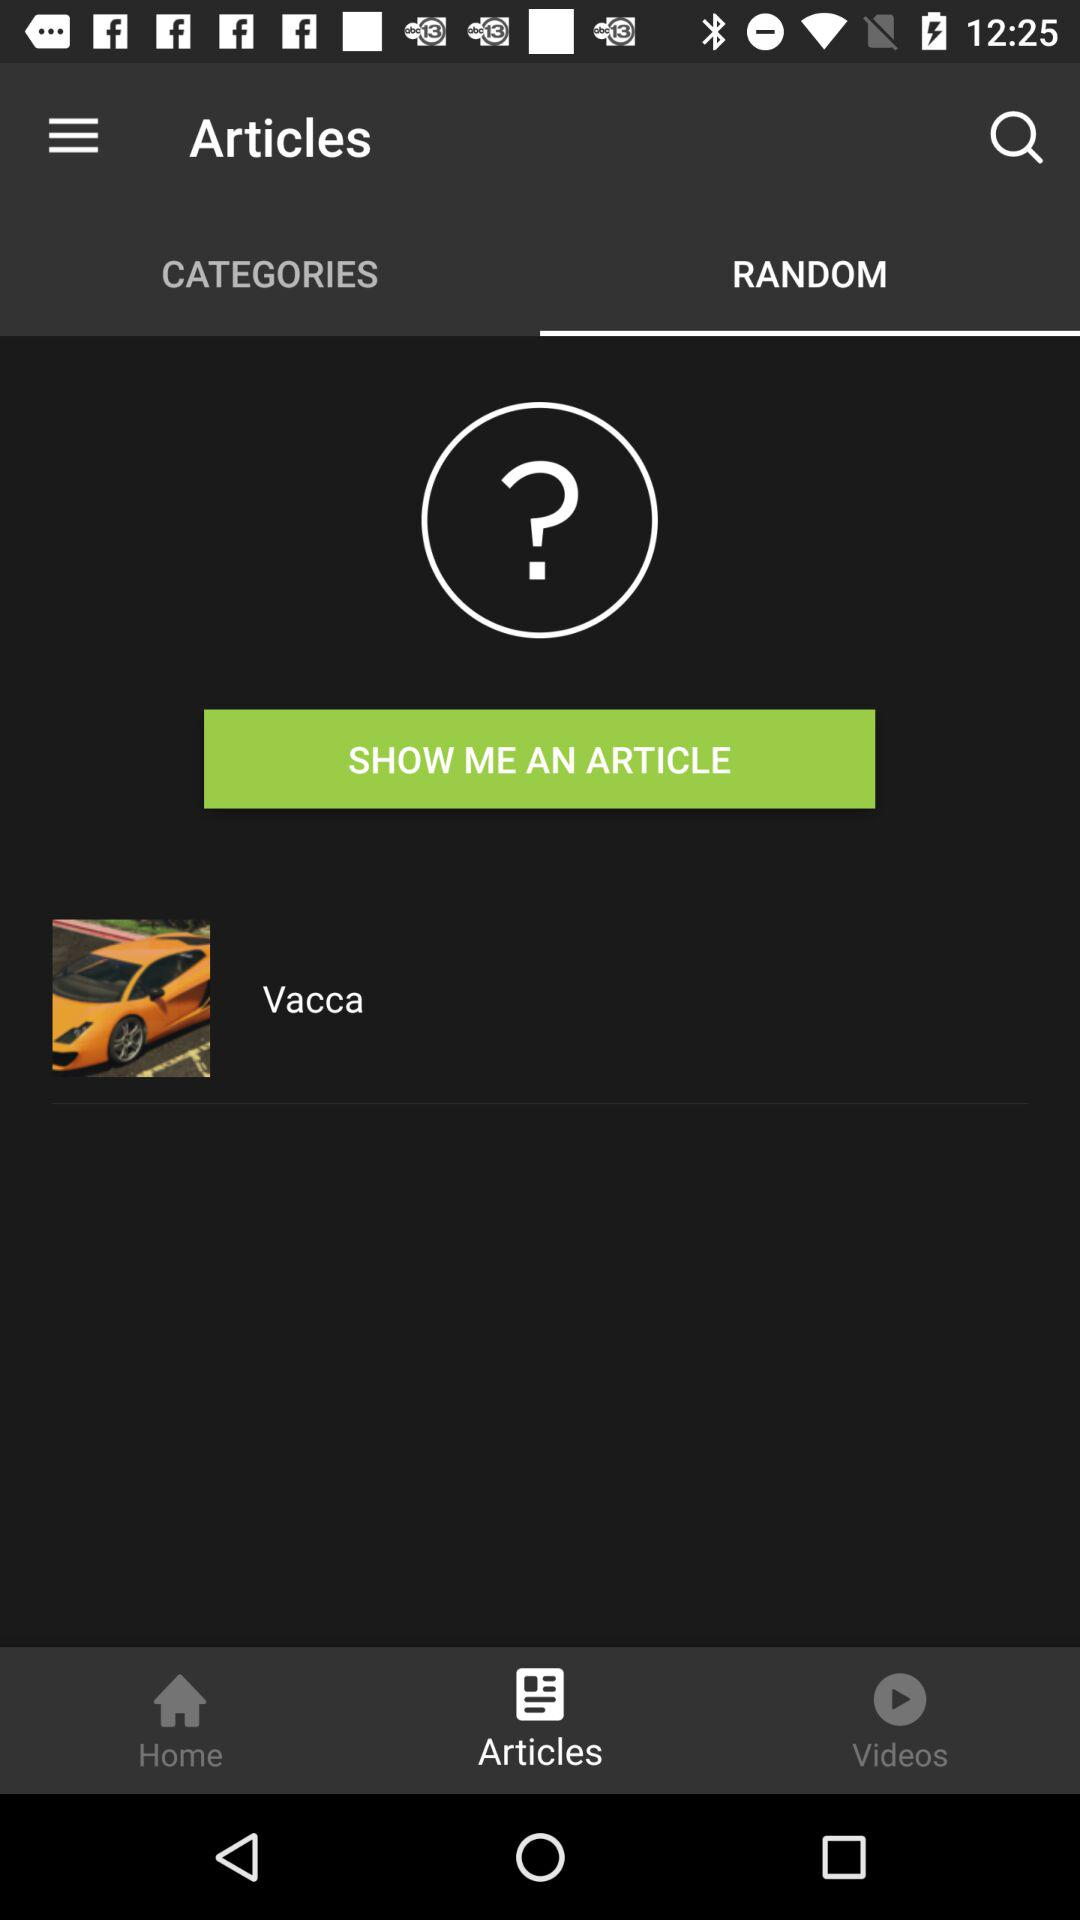Which tab of articles am I on? You are on the Random tab. 